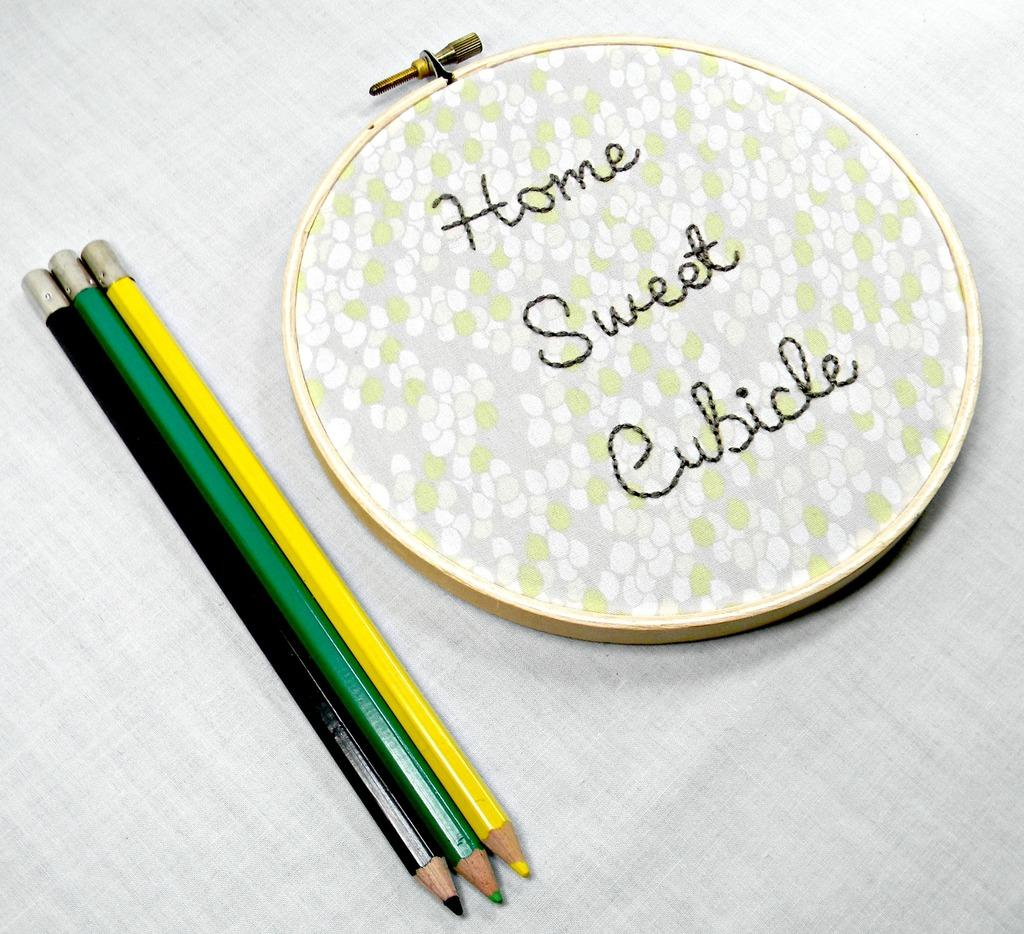What is the main object in the image? There is an object in the image, but the specific object is not mentioned in the facts. What type of stationery items can be seen in the image? There are three color pencils in the image. On what surface are the color pencils placed? The color pencils are placed on a cloth. What type of wine is being served in the image? There is no wine present in the image; it features an object and three color pencils placed on a cloth. What sense is being stimulated by the color pencils in the image? The color pencils in the image are stationary and do not stimulate any sense. 